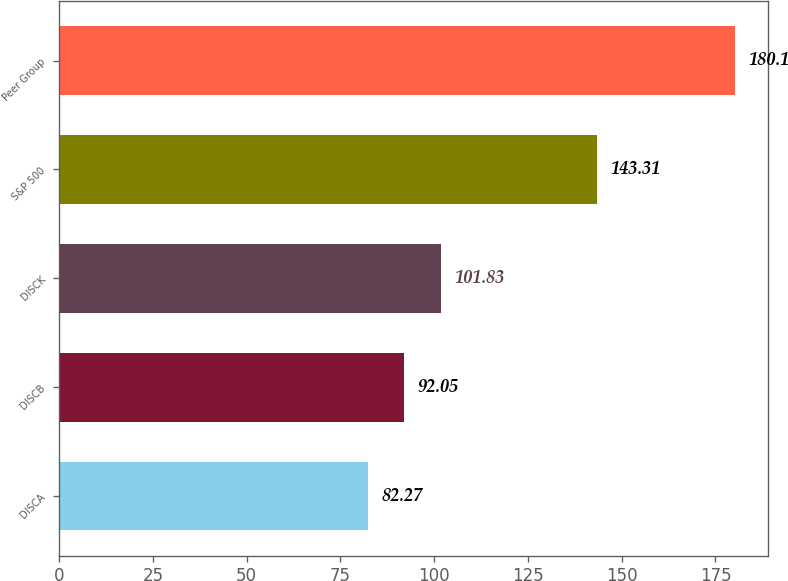Convert chart. <chart><loc_0><loc_0><loc_500><loc_500><bar_chart><fcel>DISCA<fcel>DISCB<fcel>DISCK<fcel>S&P 500<fcel>Peer Group<nl><fcel>82.27<fcel>92.05<fcel>101.83<fcel>143.31<fcel>180.1<nl></chart> 